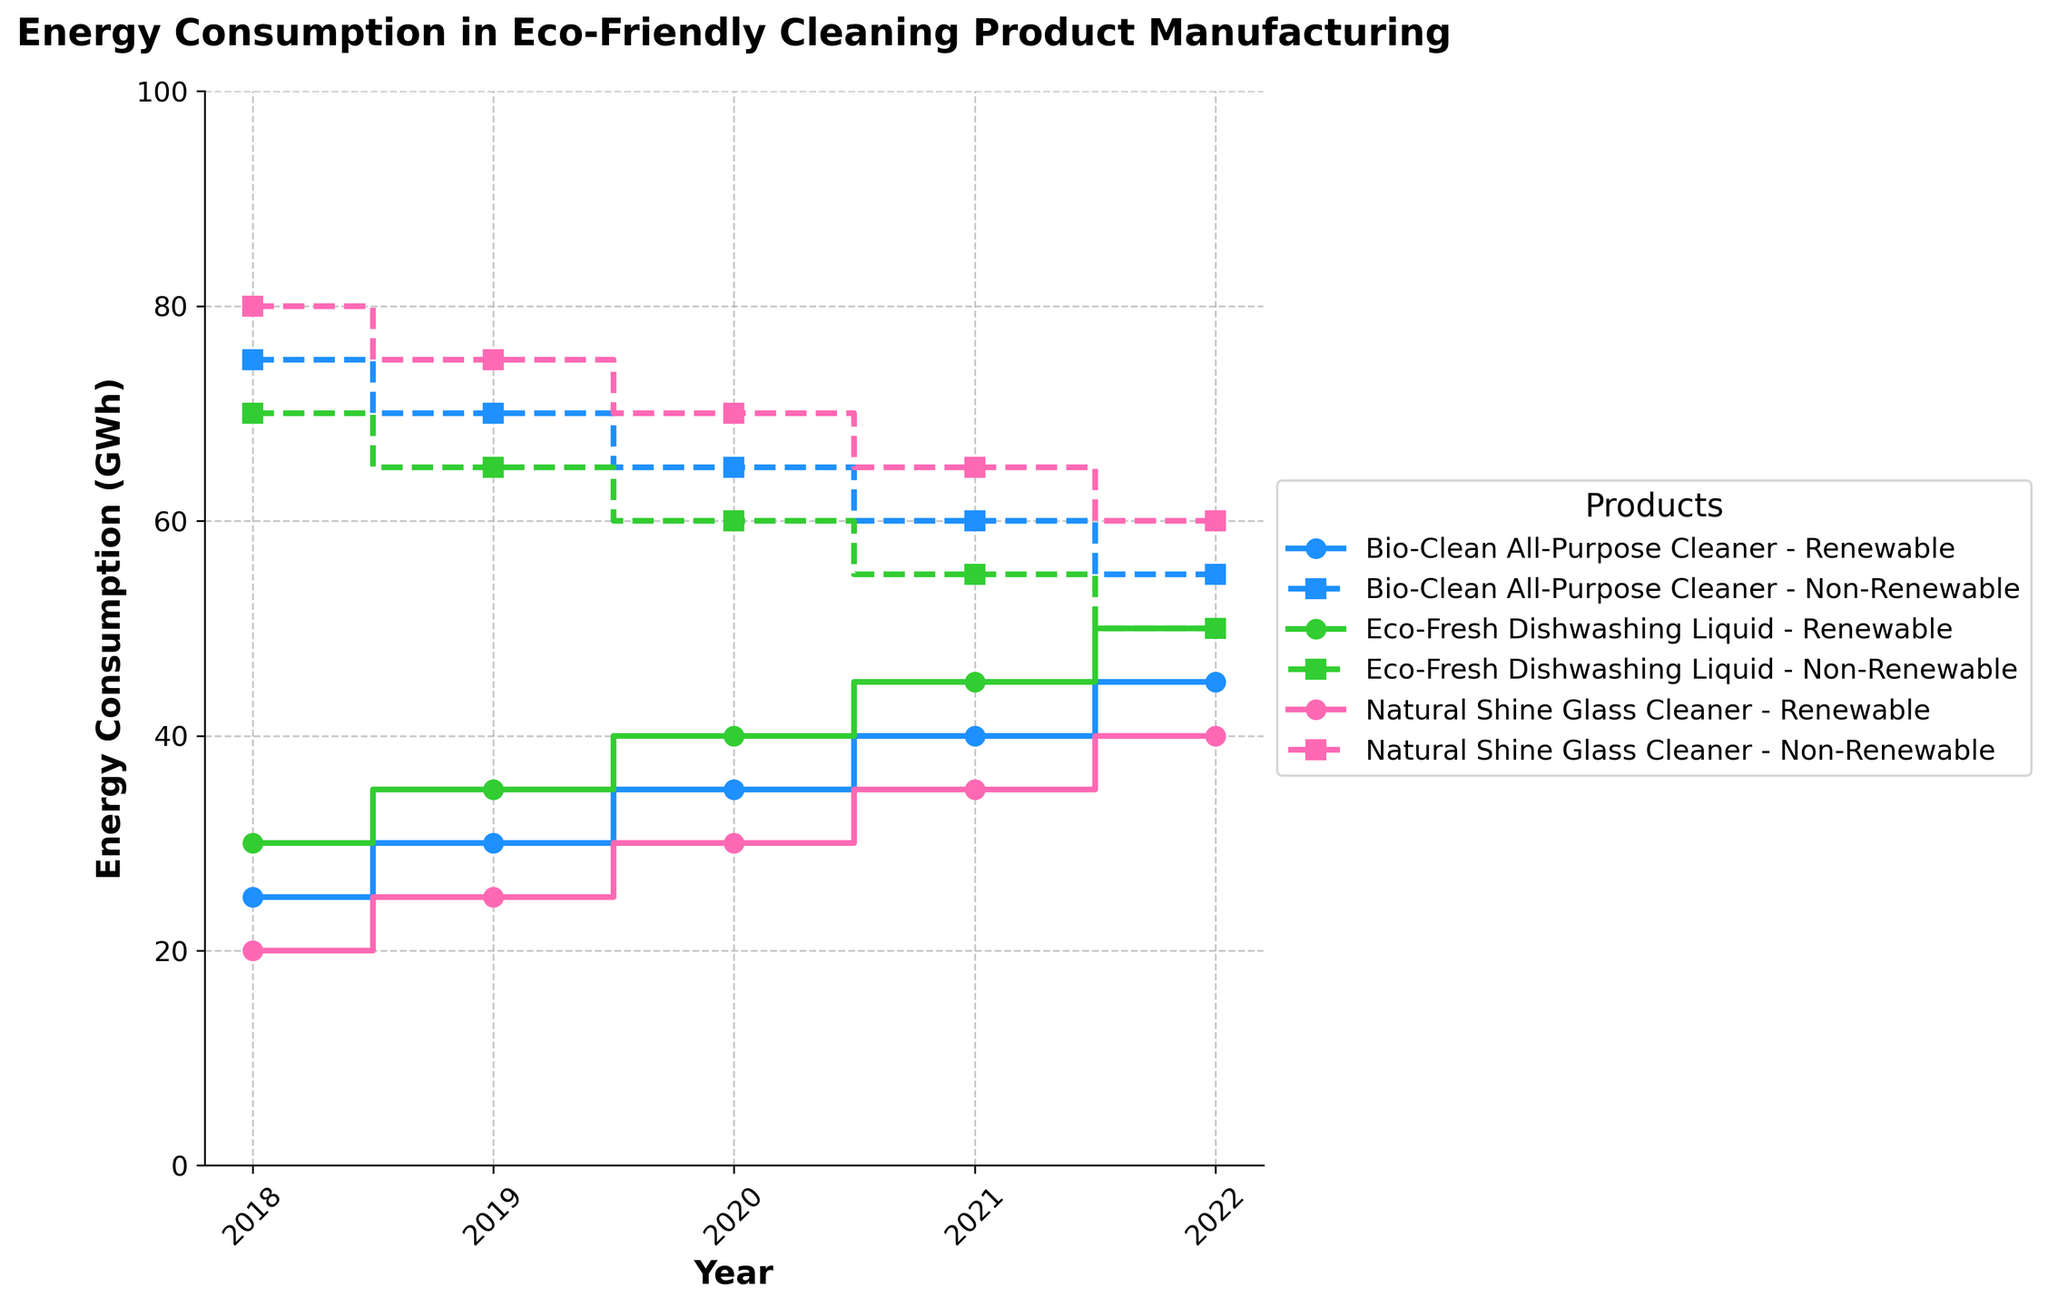What is the title of the plot? The title of the plot is usually found at the top of the figure. In this case, it mentions "Energy Consumption in Eco-Friendly Cleaning Product Manufacturing."
Answer: Energy Consumption in Eco-Friendly Cleaning Product Manufacturing What is the x-axis labeled as? The label for the x-axis is typically located along the horizontal axis. In this figure, it is labeled "Year."
Answer: Year Which product uses the most non-renewable energy in 2018? To answer this question, we examine the non-renewable energy usage lines for each product in 2018. The highest point is associated with "Natural Shine Glass Cleaner."
Answer: Natural Shine Glass Cleaner How does the renewable energy consumption trend for Bio-Clean All-Purpose Cleaner change from 2018 to 2022? Follow the renewable energy line for Bio-Clean All-Purpose Cleaner from 2018 through 2022. The values increase from 25 GWh in 2018 to 45 GWh in 2022, showing a consistent upward trend.
Answer: It increases In 2021, which product consumed equal amounts of renewable and non-renewable energy? Look at the step lines for 2021. None of the products have equal renewable and non-renewable energy usage in this year when comparing the midpoint of each step line.
Answer: None Calculate the total renewable energy consumption for Eco-Fresh Dishwashing Liquid over all the years. Sum the renewable energy GWh values for Eco-Fresh Dishwashing Liquid: 30 (2018) + 35 (2019) + 40 (2020) + 45 (2021) + 50 (2022). This results in 200 GWh.
Answer: 200 GWh Which product saw the greatest increase in renewable energy usage from 2018 to 2022? Calculate the difference in renewable energy usage from 2018 to 2022 for each product. Bio-Clean All-Purpose Cleaner increased by 20 GWh, Eco-Fresh Dishwashing Liquid increased by 20 GWh, and Natural Shine Glass Cleaner increased by 20 GWh. All have equal increases.
Answer: All products (20 GWh) How does the proportion of renewable to non-renewable energy for Natural Shine Glass Cleaner change from 2018 to 2022? Compare the proportion of renewable to non-renewable energy in 2018 (20 to 80) and in 2022 (40 to 60). Initially, renewable makes up 20% of the total, and by 2022, it makes up 40%. The proportion has increased.
Answer: It increased Which year shows the least amount of non-renewable energy consumption overall for all products? Add the non-renewable energy totals for all products in each year. 2022 has the least non-renewable energy consumption with values 55, 50, and 60 GWh per product.
Answer: 2022 